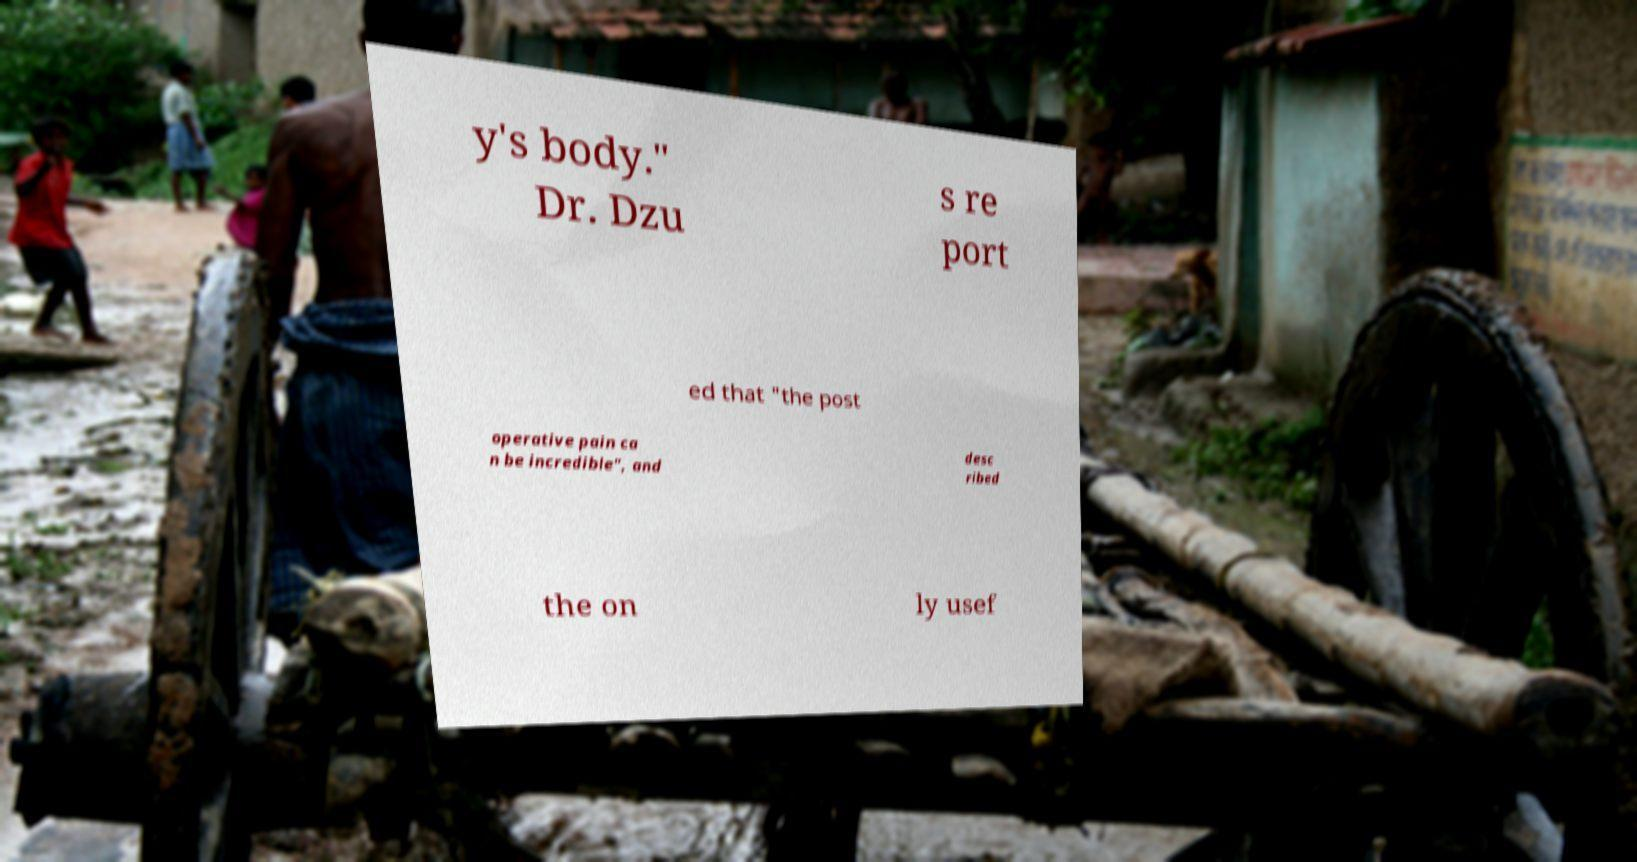Could you assist in decoding the text presented in this image and type it out clearly? y's body." Dr. Dzu s re port ed that "the post operative pain ca n be incredible", and desc ribed the on ly usef 